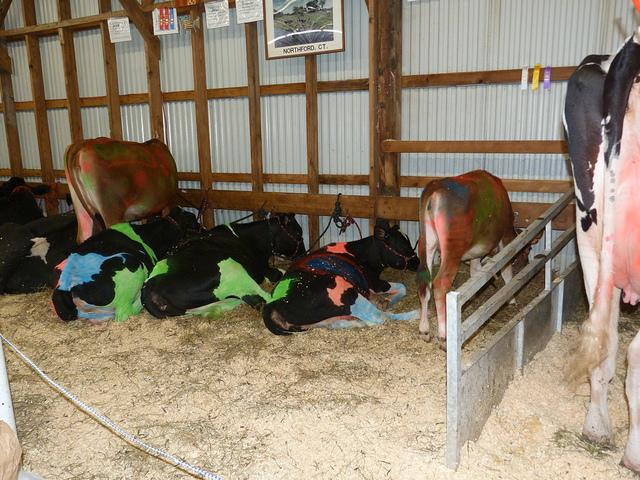What color is the black cow laying down to the right of the green cows? Please explain your reasoning. pink. The color is pink. 